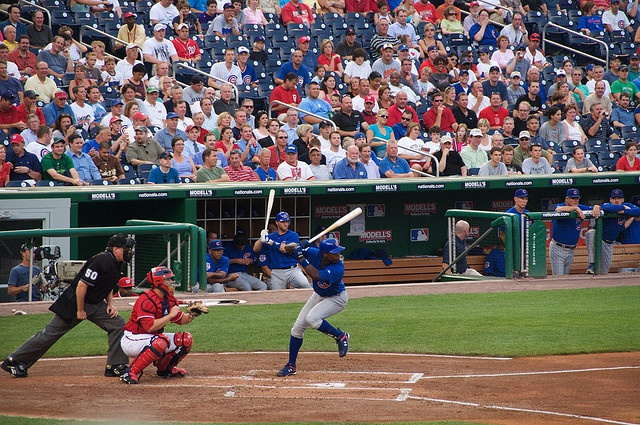Describe the objects in this image and their specific colors. I can see people in black, brown, lavender, and gray tones, people in black, gray, brown, and maroon tones, people in black, brown, and maroon tones, people in black, navy, darkgray, and gray tones, and people in black, navy, and gray tones in this image. 